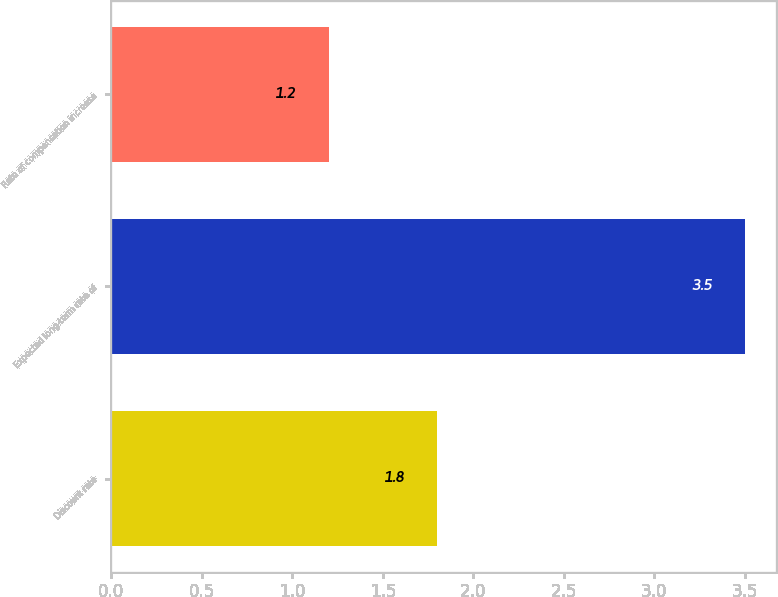<chart> <loc_0><loc_0><loc_500><loc_500><bar_chart><fcel>Discount rate<fcel>Expected long-term rate of<fcel>Rate of compensation increase<nl><fcel>1.8<fcel>3.5<fcel>1.2<nl></chart> 